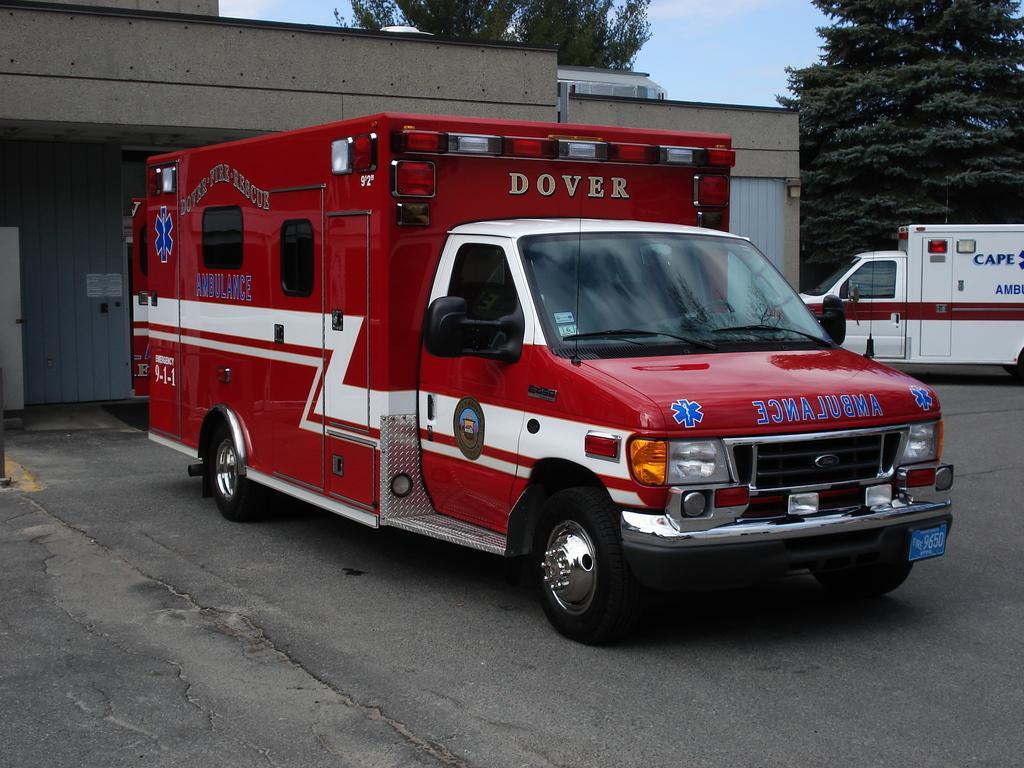In one or two sentences, can you explain what this image depicts? In this image we can see motor vehicles on the road, buildings, trees and sky with clouds. 